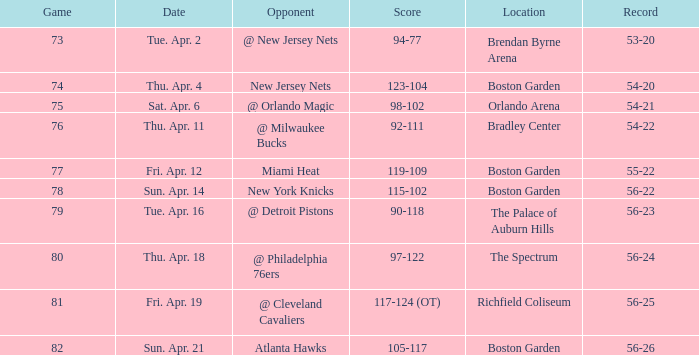In what location was game 78 held? Boston Garden. 